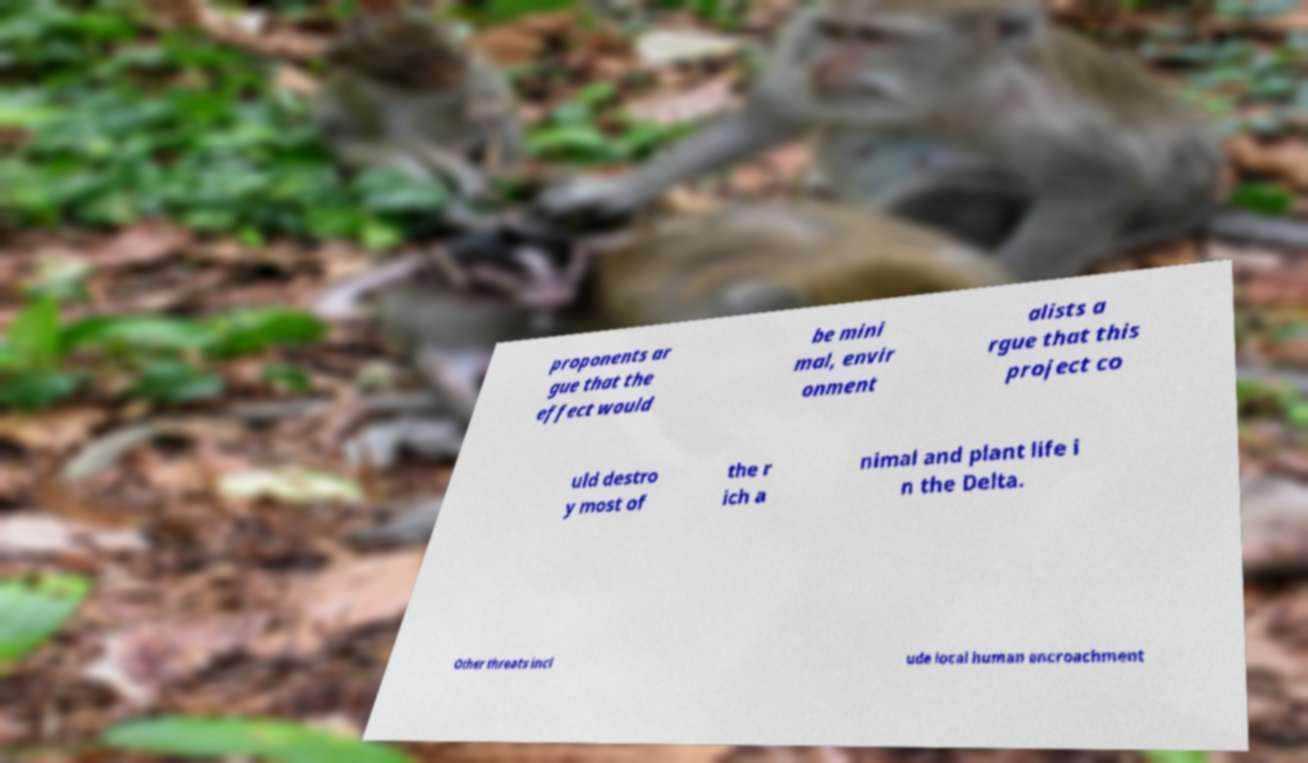There's text embedded in this image that I need extracted. Can you transcribe it verbatim? proponents ar gue that the effect would be mini mal, envir onment alists a rgue that this project co uld destro y most of the r ich a nimal and plant life i n the Delta. Other threats incl ude local human encroachment 